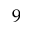Convert formula to latex. <formula><loc_0><loc_0><loc_500><loc_500>9</formula> 